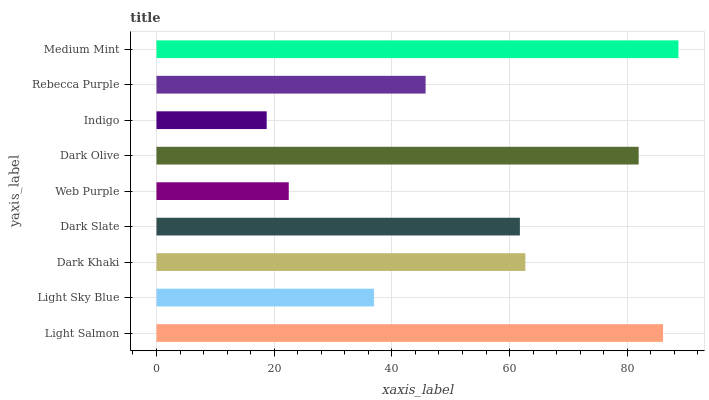Is Indigo the minimum?
Answer yes or no. Yes. Is Medium Mint the maximum?
Answer yes or no. Yes. Is Light Sky Blue the minimum?
Answer yes or no. No. Is Light Sky Blue the maximum?
Answer yes or no. No. Is Light Salmon greater than Light Sky Blue?
Answer yes or no. Yes. Is Light Sky Blue less than Light Salmon?
Answer yes or no. Yes. Is Light Sky Blue greater than Light Salmon?
Answer yes or no. No. Is Light Salmon less than Light Sky Blue?
Answer yes or no. No. Is Dark Slate the high median?
Answer yes or no. Yes. Is Dark Slate the low median?
Answer yes or no. Yes. Is Rebecca Purple the high median?
Answer yes or no. No. Is Light Sky Blue the low median?
Answer yes or no. No. 